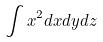Convert formula to latex. <formula><loc_0><loc_0><loc_500><loc_500>\int x ^ { 2 } d x d y d z</formula> 